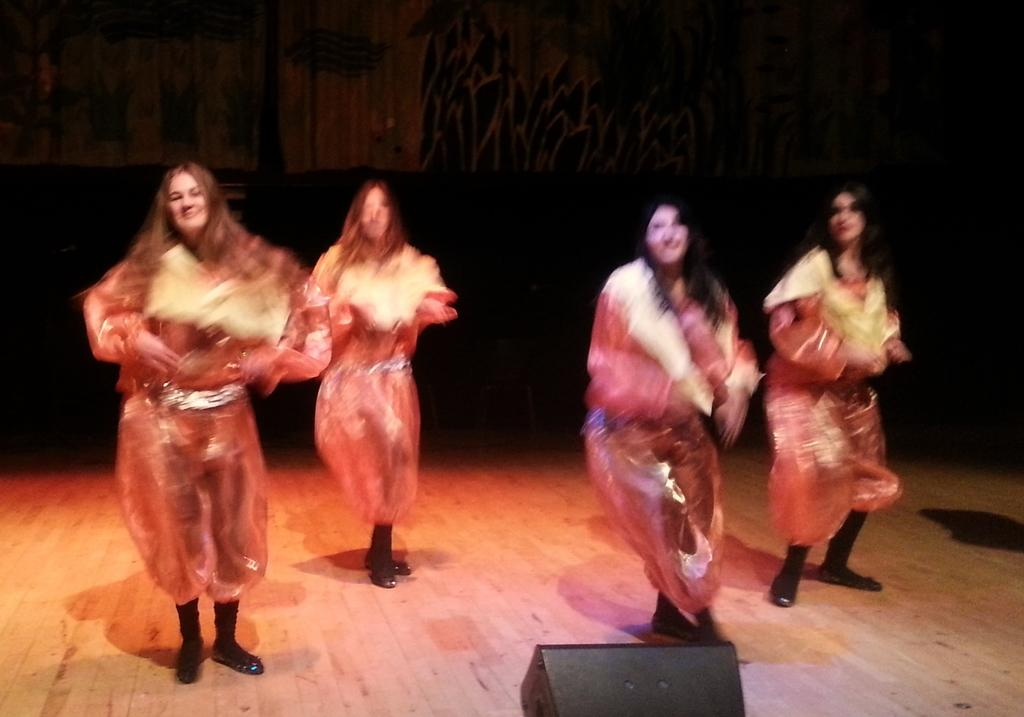How many girls are in the image? There are four girls in the image. What are the girls wearing? The girls are wearing shiny costumes. What type of shoes are the girls wearing? The girls are wearing black shoes. Where are the girls dancing? The girls are dancing on a wooden floor. What can be seen in the middle of the floor? There is a light in the middle of the floor. What is visible in the background of the image? There is a wall visible in the background. What type of trucks are parked near the girls in the image? There are no trucks present in the image; it features four girls dancing on a wooden floor. How comfortable are the girls in the image? The provided facts do not give any information about the comfort level of the girls, so it cannot be determined from the image. 